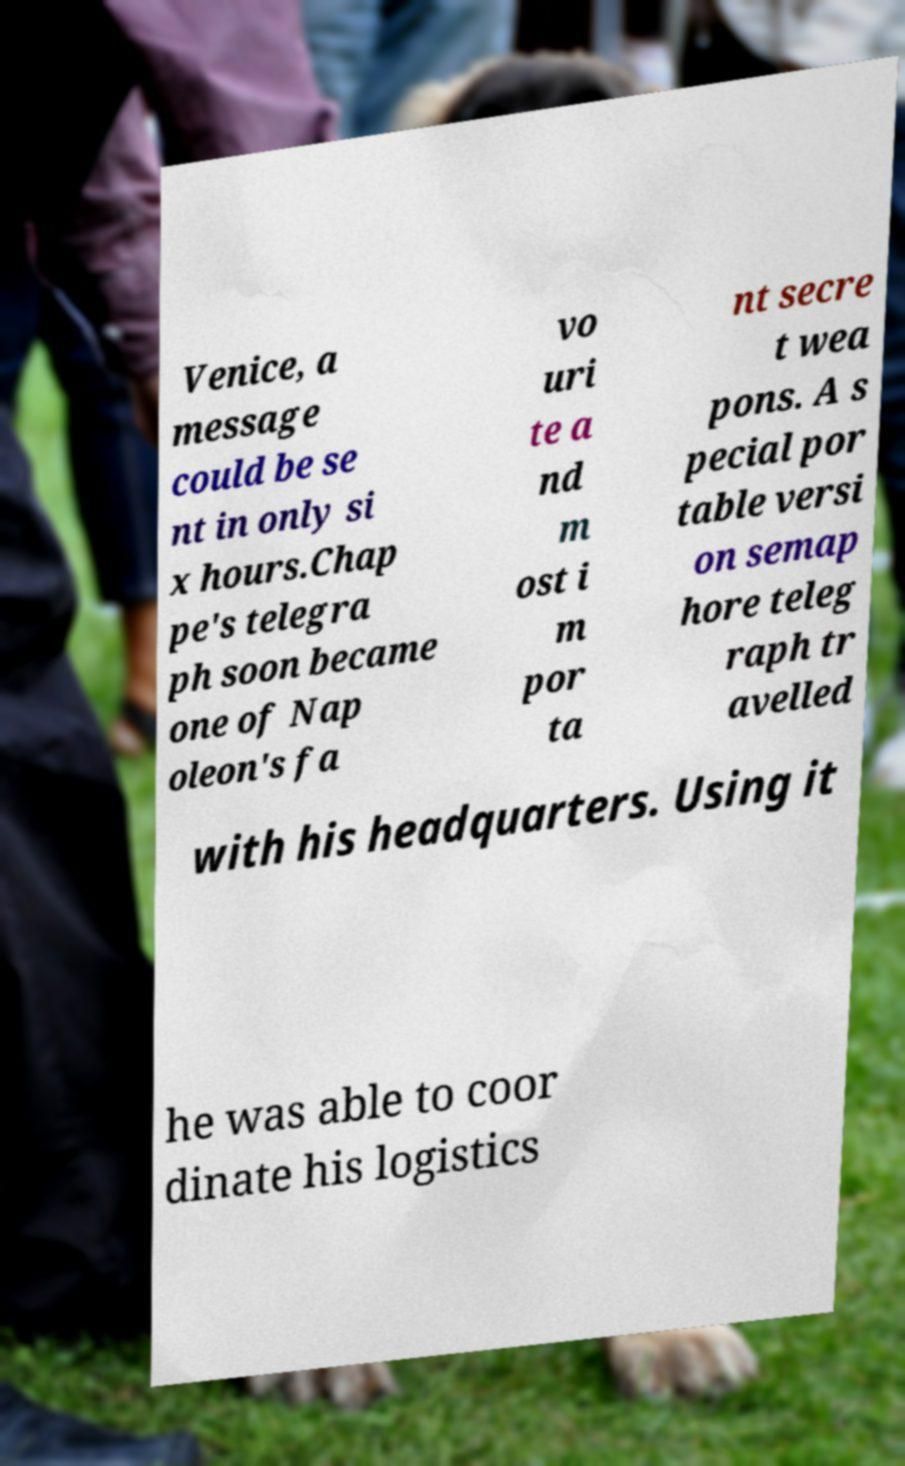Can you accurately transcribe the text from the provided image for me? Venice, a message could be se nt in only si x hours.Chap pe's telegra ph soon became one of Nap oleon's fa vo uri te a nd m ost i m por ta nt secre t wea pons. A s pecial por table versi on semap hore teleg raph tr avelled with his headquarters. Using it he was able to coor dinate his logistics 